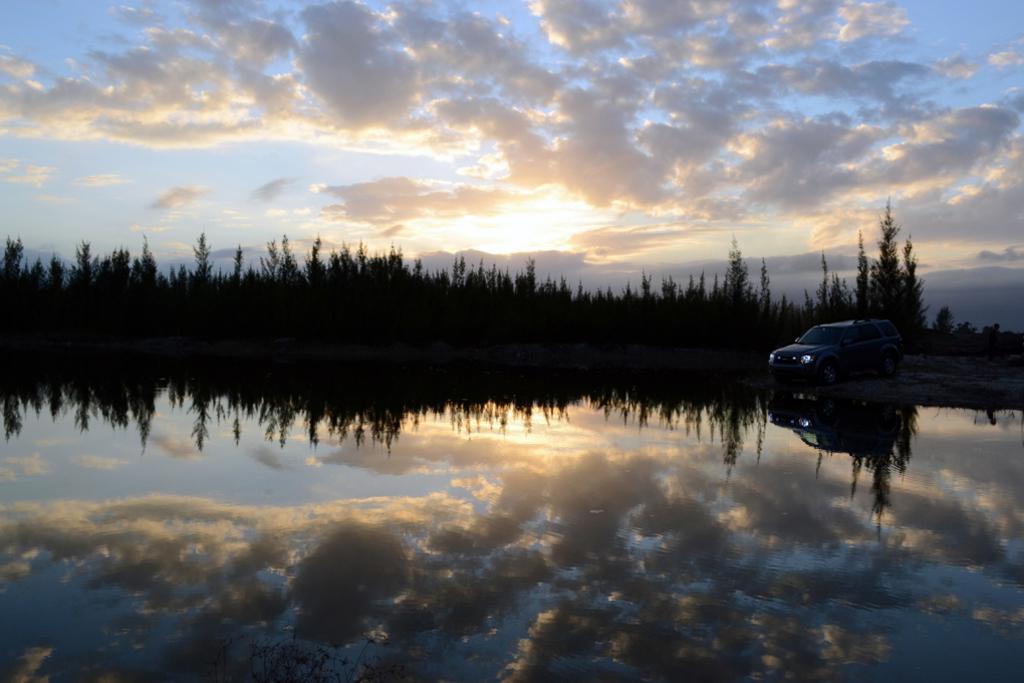Describe this image in one or two sentences. In this image in front there is water. There is a car. In the background of the image there are trees and sky. 